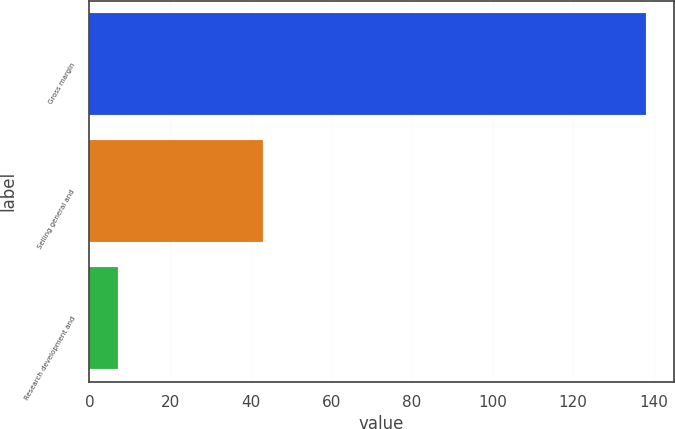<chart> <loc_0><loc_0><loc_500><loc_500><bar_chart><fcel>Gross margin<fcel>Selling general and<fcel>Research development and<nl><fcel>138<fcel>43<fcel>7<nl></chart> 